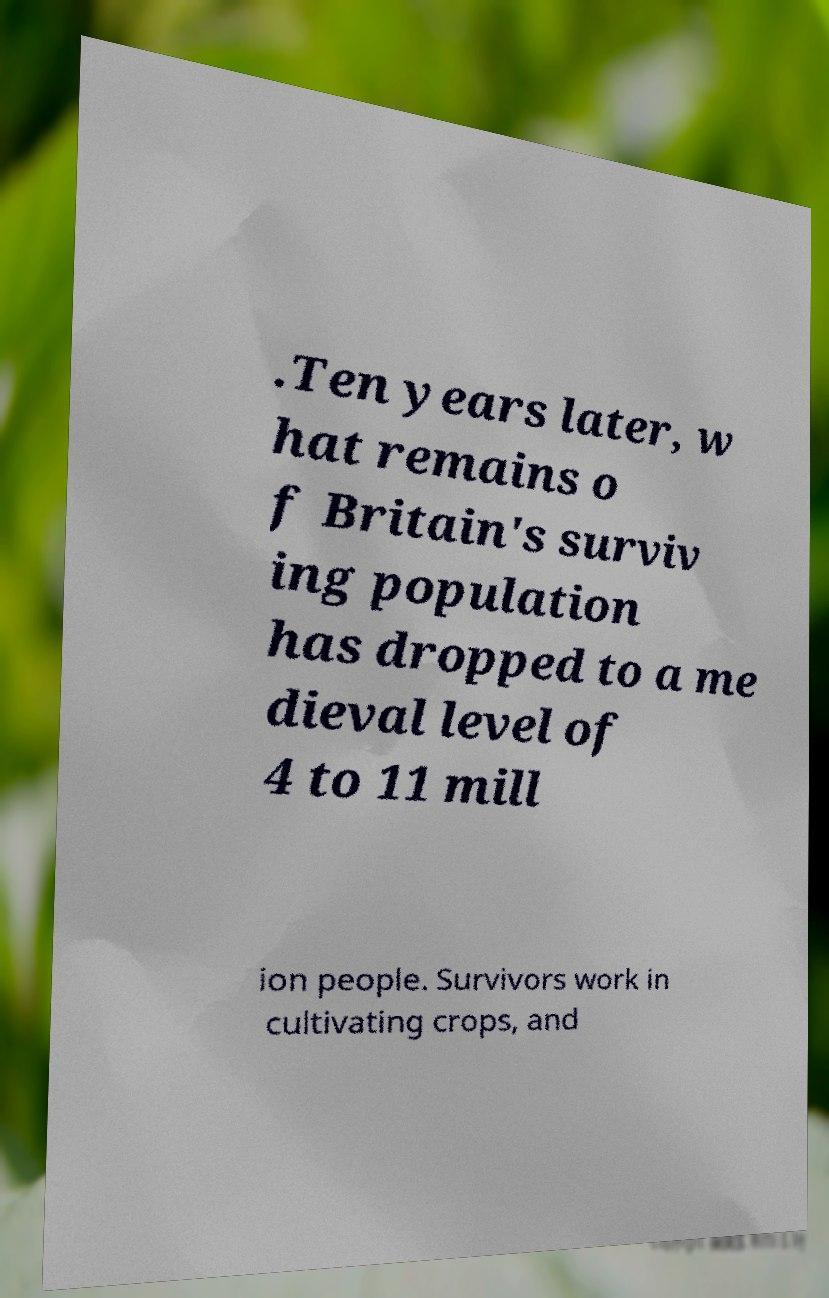Could you extract and type out the text from this image? .Ten years later, w hat remains o f Britain's surviv ing population has dropped to a me dieval level of 4 to 11 mill ion people. Survivors work in cultivating crops, and 